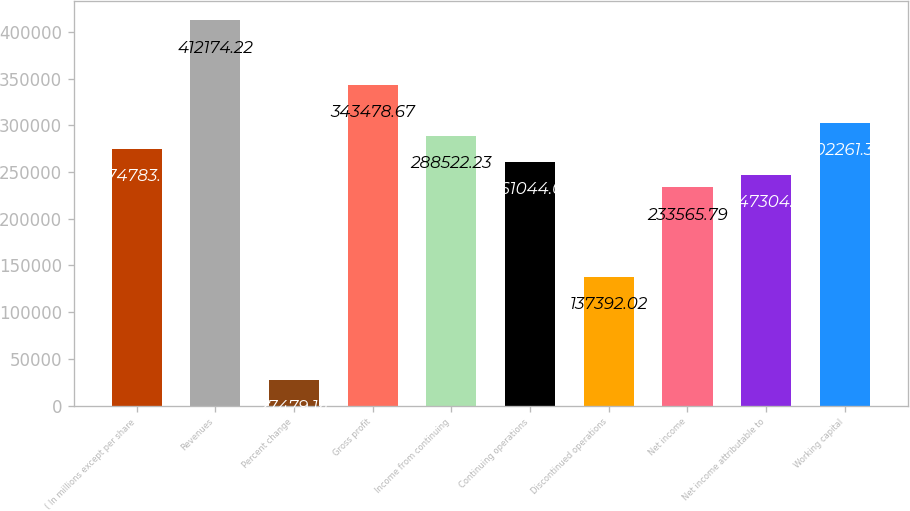Convert chart to OTSL. <chart><loc_0><loc_0><loc_500><loc_500><bar_chart><fcel>( In millions except per share<fcel>Revenues<fcel>Percent change<fcel>Gross profit<fcel>Income from continuing<fcel>Continuing operations<fcel>Discontinued operations<fcel>Net income<fcel>Net income attributable to<fcel>Working capital<nl><fcel>274783<fcel>412174<fcel>27479.1<fcel>343479<fcel>288522<fcel>261044<fcel>137392<fcel>233566<fcel>247305<fcel>302261<nl></chart> 